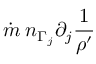<formula> <loc_0><loc_0><loc_500><loc_500>\dot { m } \, n _ { \Gamma _ { j } } \partial _ { j } \frac { 1 } { \rho ^ { \prime } }</formula> 